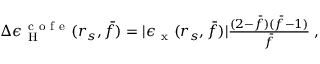Convert formula to latex. <formula><loc_0><loc_0><loc_500><loc_500>\begin{array} { r } { \Delta \epsilon _ { H } ^ { c o f e } ( r _ { s } , \bar { f } ) = | \epsilon _ { x } ( r _ { s } , \bar { f } ) | \frac { ( 2 - \bar { f } ) ( \bar { f } - 1 ) } { \bar { f } } \, , } \end{array}</formula> 